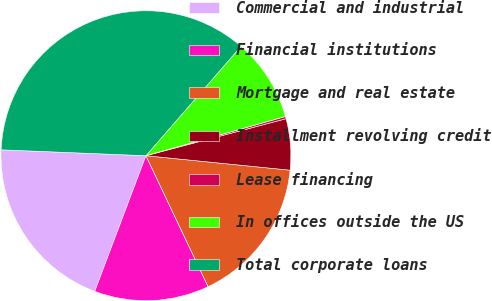Convert chart. <chart><loc_0><loc_0><loc_500><loc_500><pie_chart><fcel>Commercial and industrial<fcel>Financial institutions<fcel>Mortgage and real estate<fcel>Installment revolving credit<fcel>Lease financing<fcel>In offices outside the US<fcel>Total corporate loans<nl><fcel>19.9%<fcel>12.8%<fcel>16.35%<fcel>5.7%<fcel>0.25%<fcel>9.25%<fcel>35.74%<nl></chart> 